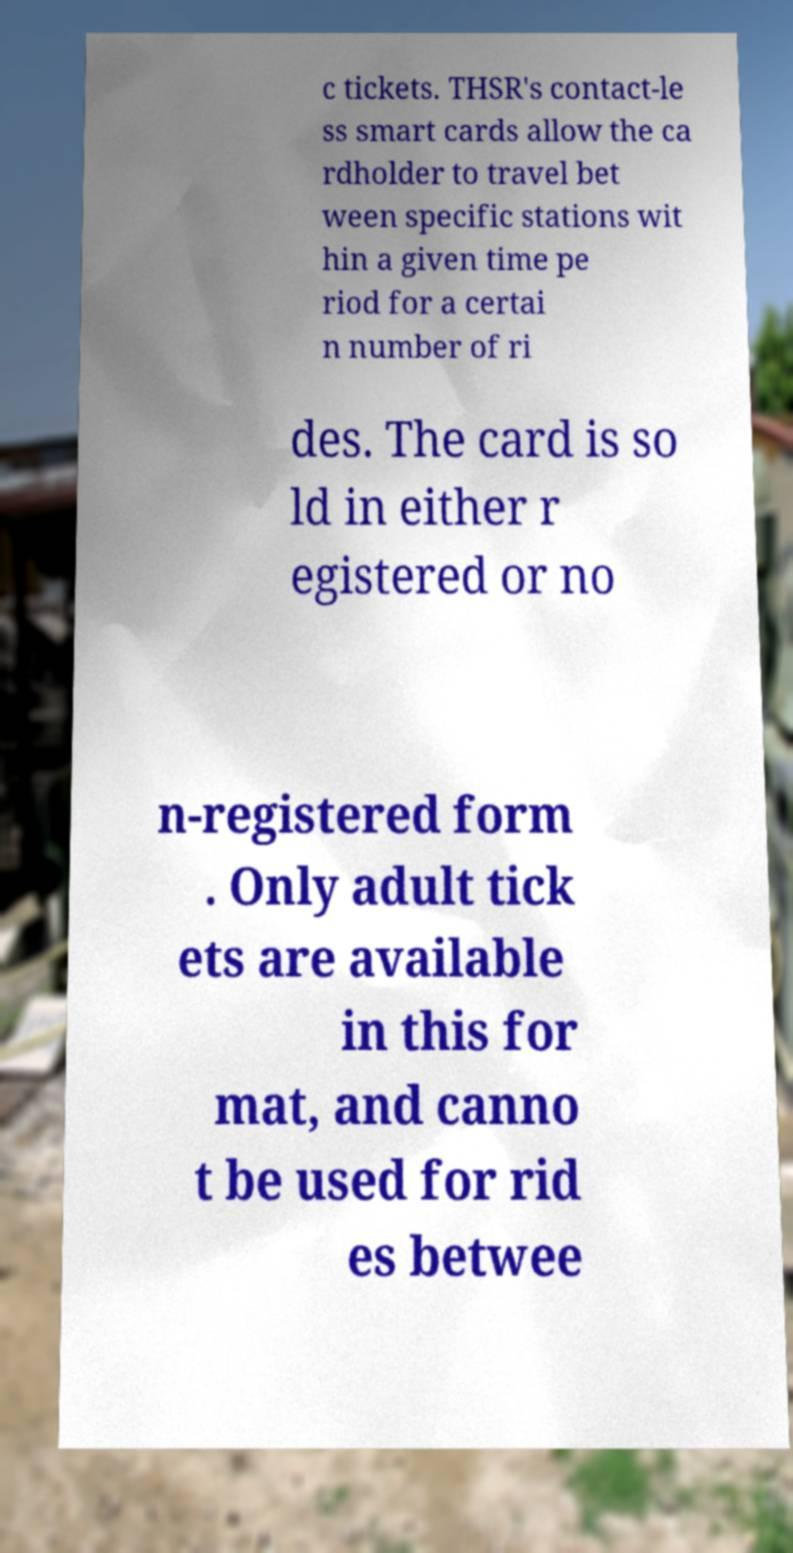What messages or text are displayed in this image? I need them in a readable, typed format. c tickets. THSR's contact-le ss smart cards allow the ca rdholder to travel bet ween specific stations wit hin a given time pe riod for a certai n number of ri des. The card is so ld in either r egistered or no n-registered form . Only adult tick ets are available in this for mat, and canno t be used for rid es betwee 